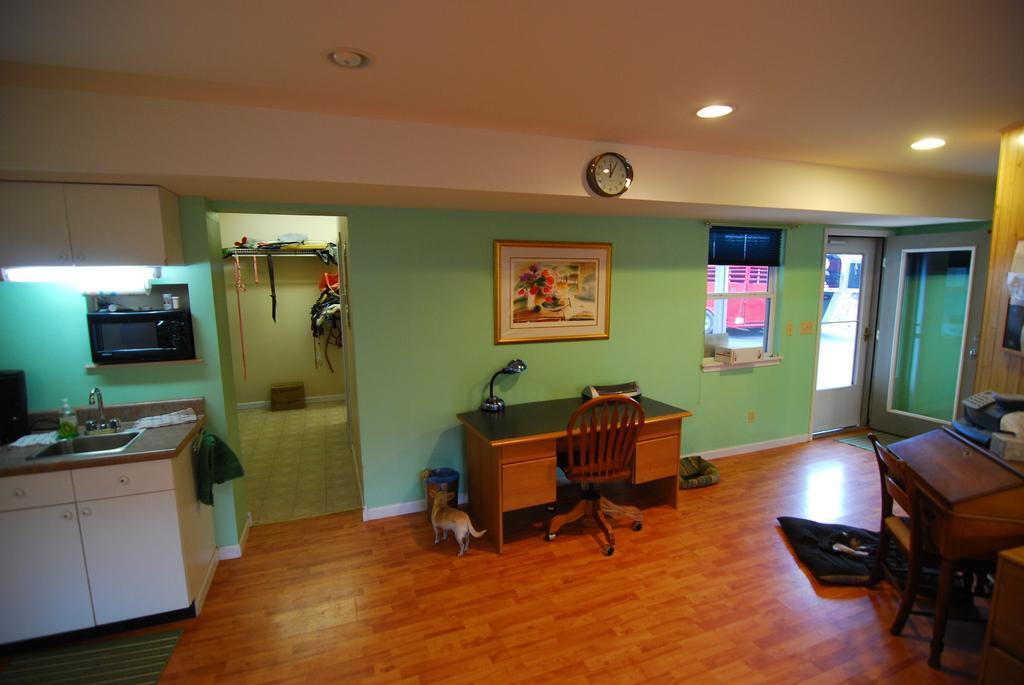How would you summarize this image in a sentence or two? In this image I can see a cabinet, wash basin, study table, chair and a keyboard on the floor. In the background I can see a wall painting on the wall, window, doors and oven. On the top I can see a clock is mounted. This image is taken in a house. 